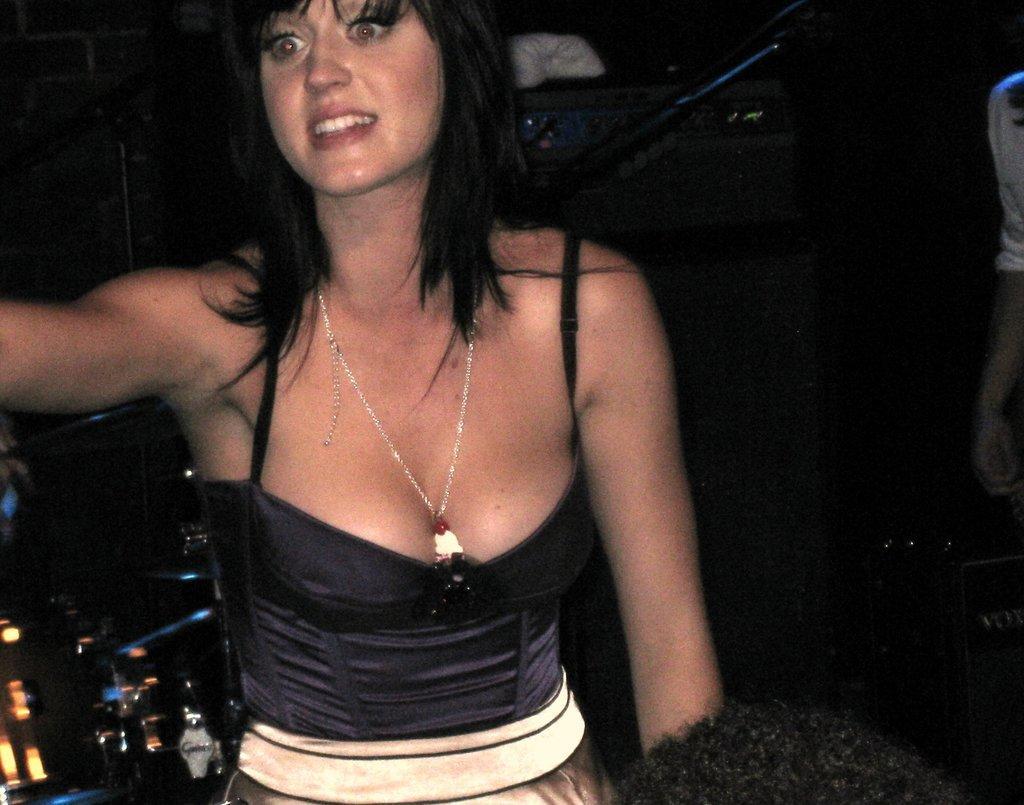Describe this image in one or two sentences. In this image there is a woman. 